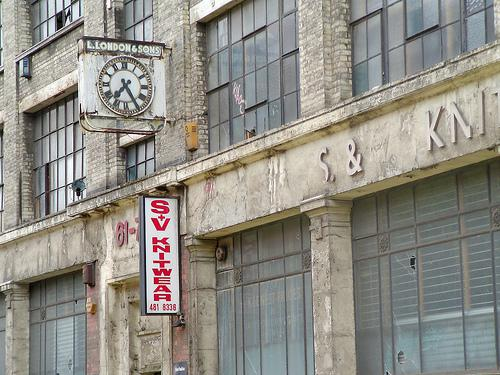Question: how many clock are there?
Choices:
A. 2.
B. 4.
C. 6.
D. 1.
Answer with the letter. Answer: D Question: what is the color of the clock?
Choices:
A. White and black.
B. Red, white, and blue.
C. Orange and brown.
D. Yellow and green.
Answer with the letter. Answer: A Question: what is the color of the building?
Choices:
A. Brown.
B. Black.
C. White.
D. Beige.
Answer with the letter. Answer: A Question: where are the windows?
Choices:
A. In the doors.
B. In the building wall.
C. Over the kitchen sink.
D. Next to the bathtub.
Answer with the letter. Answer: B 